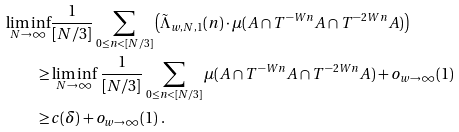<formula> <loc_0><loc_0><loc_500><loc_500>\liminf _ { N \to \infty } & \frac { 1 } { [ N / 3 ] } \sum _ { 0 \leq n < [ N / 3 ] } \left ( \tilde { \Lambda } _ { w , N , 1 } ( n ) \cdot \mu ( A \cap T ^ { - W n } A \cap T ^ { - 2 W n } A ) \right ) \\ \geq & \liminf _ { N \to \infty } \, \frac { 1 } { [ N / 3 ] } \sum _ { 0 \leq n < [ N / 3 ] } \mu ( A \cap T ^ { - W n } A \cap T ^ { - 2 W n } A ) + o _ { w \to \infty } ( 1 ) \\ \geq & c ( \delta ) + o _ { w \to \infty } ( 1 ) \ .</formula> 